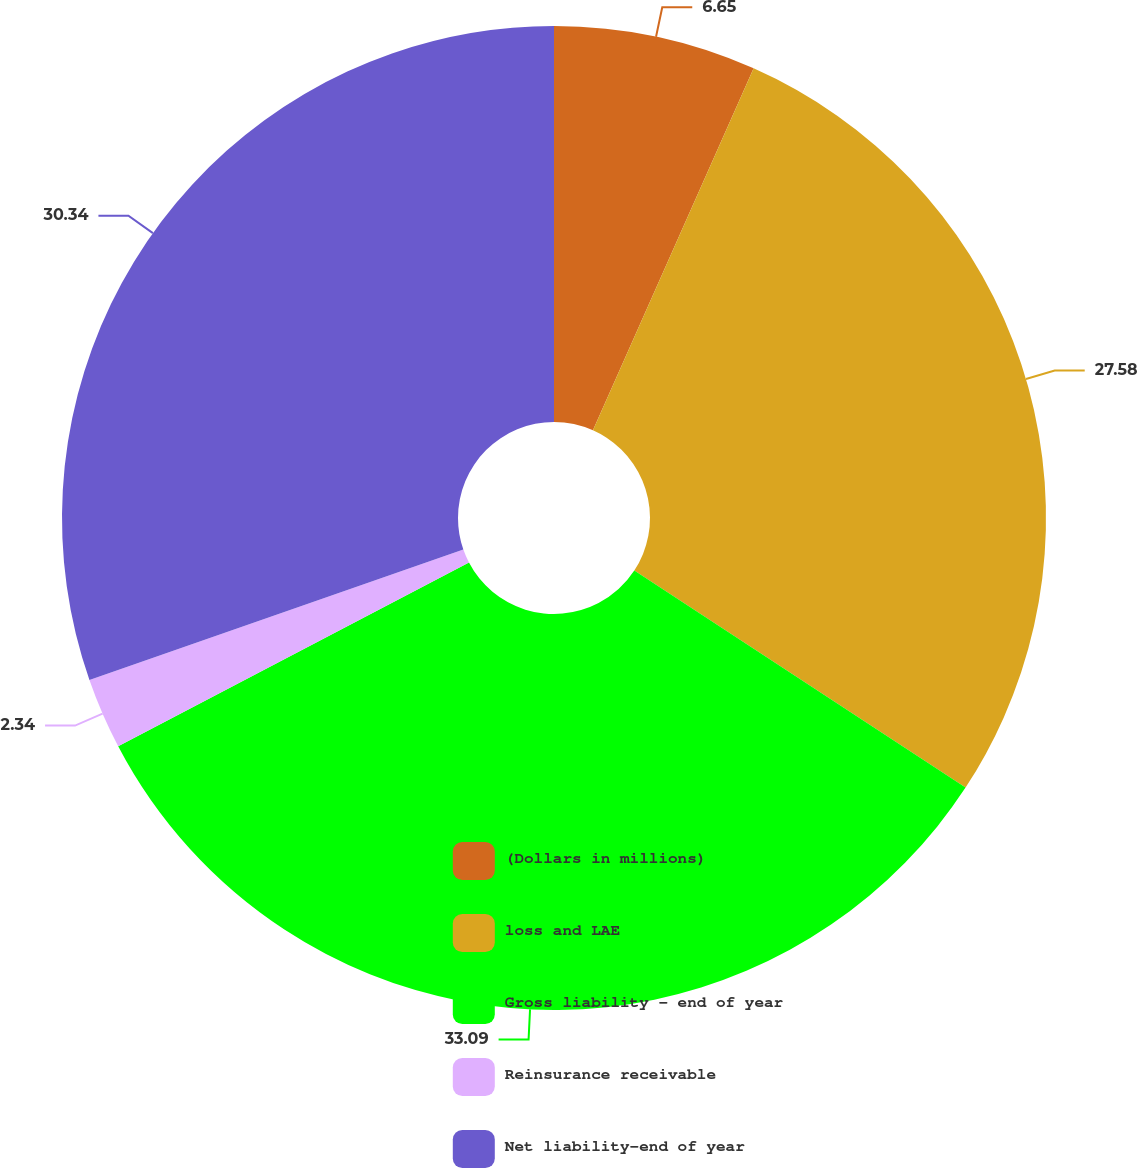<chart> <loc_0><loc_0><loc_500><loc_500><pie_chart><fcel>(Dollars in millions)<fcel>loss and LAE<fcel>Gross liability - end of year<fcel>Reinsurance receivable<fcel>Net liability-end of year<nl><fcel>6.65%<fcel>27.58%<fcel>33.09%<fcel>2.34%<fcel>30.34%<nl></chart> 